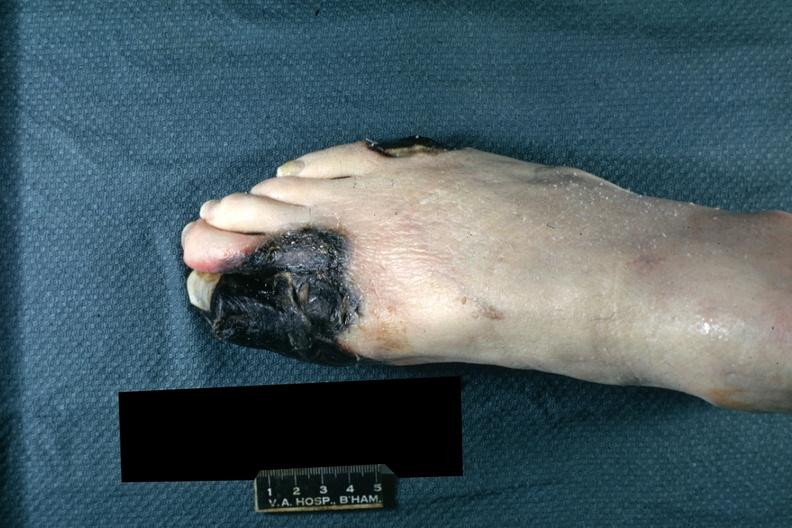s gangrene present?
Answer the question using a single word or phrase. Yes 